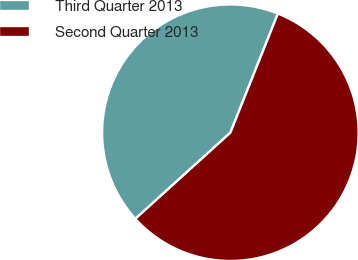Convert chart. <chart><loc_0><loc_0><loc_500><loc_500><pie_chart><fcel>Third Quarter 2013<fcel>Second Quarter 2013<nl><fcel>42.76%<fcel>57.24%<nl></chart> 